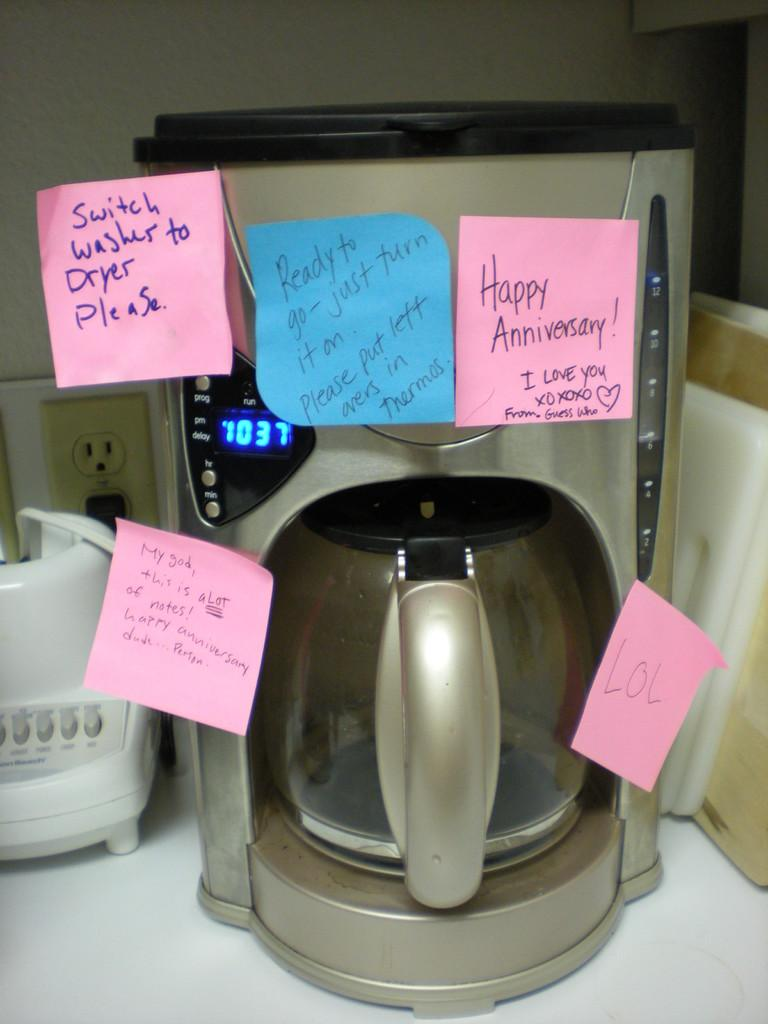<image>
Write a terse but informative summary of the picture. Numerous post it notes are stuck to a coffee maker, one saying Happy Anniversary and the other giving instructions for tasks. 